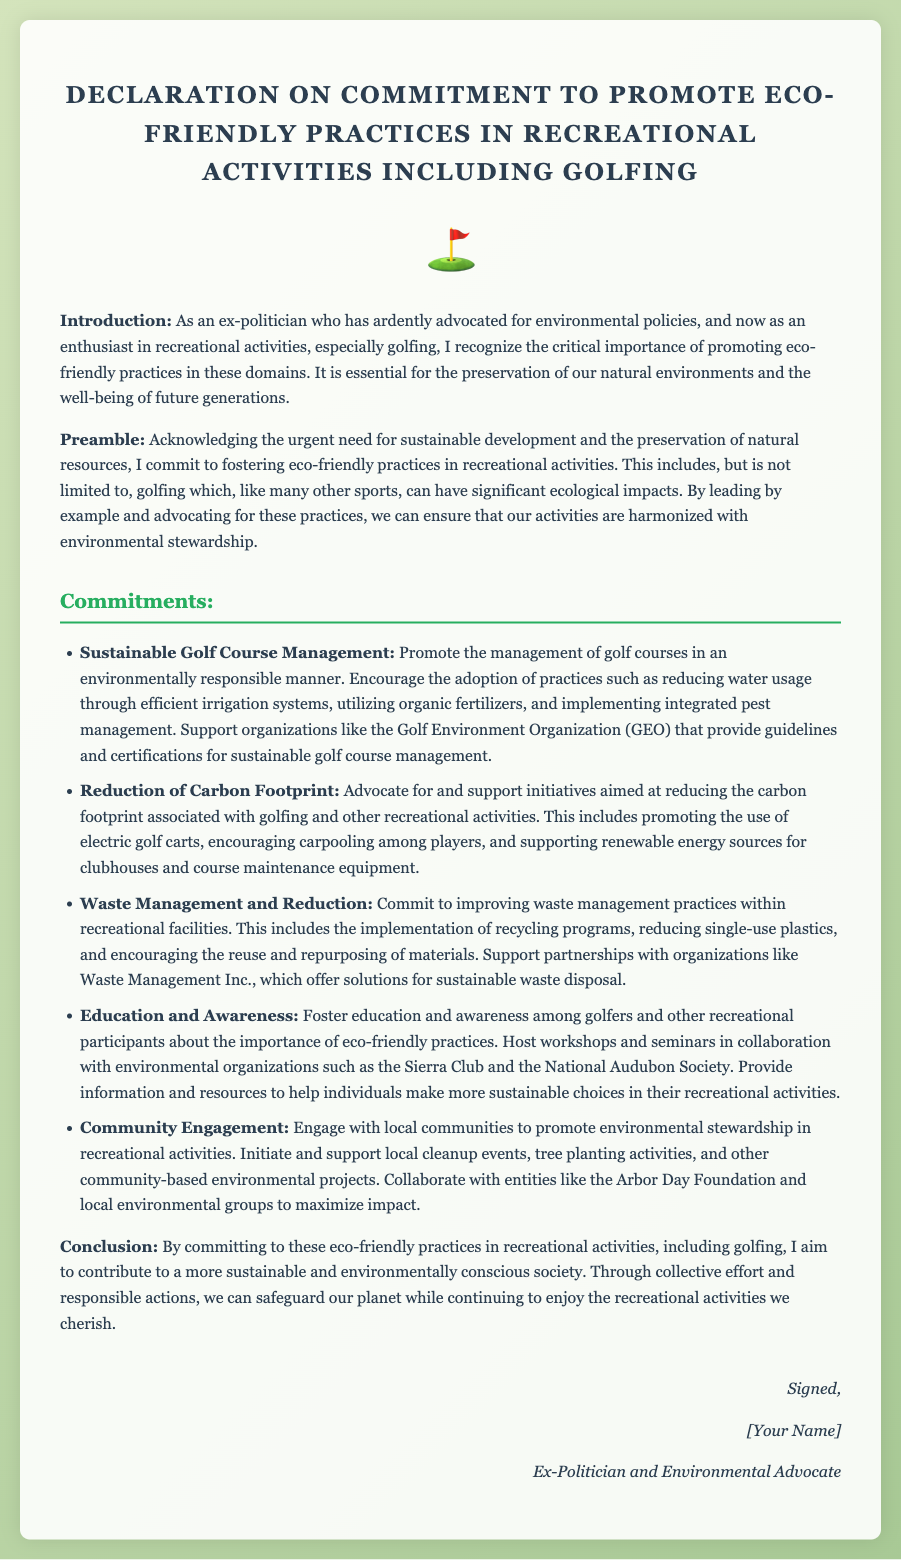What is the title of the document? The title of the document is clearly stated at the top of the rendered page.
Answer: Declaration on Commitment to Promote Eco-Friendly Practices in Recreational Activities Including Golfing Who is the intended audience of the declaration? The intended audience includes participants in recreational activities, particularly golfers, as implied in the introduction and commitments.
Answer: Golfers What organization supports sustainable golf course management? The document mentions an organization that provides guidelines and certifications for sustainable management in golf.
Answer: Golf Environment Organization (GEO) What is one way to reduce carbon footprint mentioned in the commitments? The commitments detail several approaches, one of which involves the use of specific types of vehicles for golfing.
Answer: Electric golf carts What type of initiatives does the declaration encourage? Multiple initiatives are outlined in the commitments, aimed at improving recreational practices for environmental sustainability.
Answer: Eco-friendly practices How many commitments are detailed in the document? The commitments section is organized with a bulleted list, and the number of items indicates the total commitments presented.
Answer: Five What is the primary goal of the declaration? The overall intention of the declaration is summarized in the conclusion, indicating the purpose of these commitments.
Answer: Contribute to a more sustainable and environmentally conscious society What activities does the declaration specifically mention for community engagement? Examples of activities for engaging local communities are provided within the commitments section.
Answer: Local cleanup events Who signs the declaration? The signature section indicates who the document is from, confirming the identity of the signer based on the format provided.
Answer: Ex-Politician and Environmental Advocate 